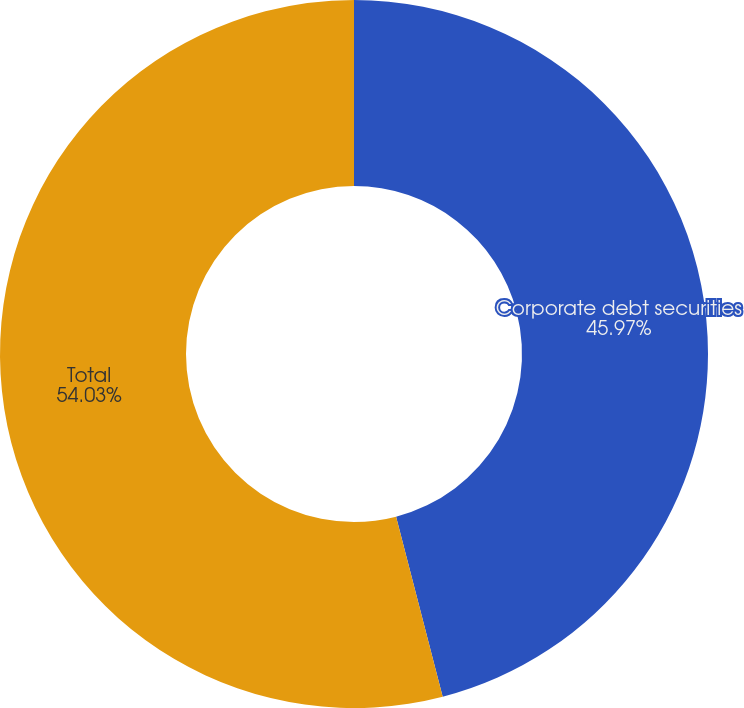Convert chart to OTSL. <chart><loc_0><loc_0><loc_500><loc_500><pie_chart><fcel>Corporate debt securities<fcel>Total<nl><fcel>45.97%<fcel>54.03%<nl></chart> 